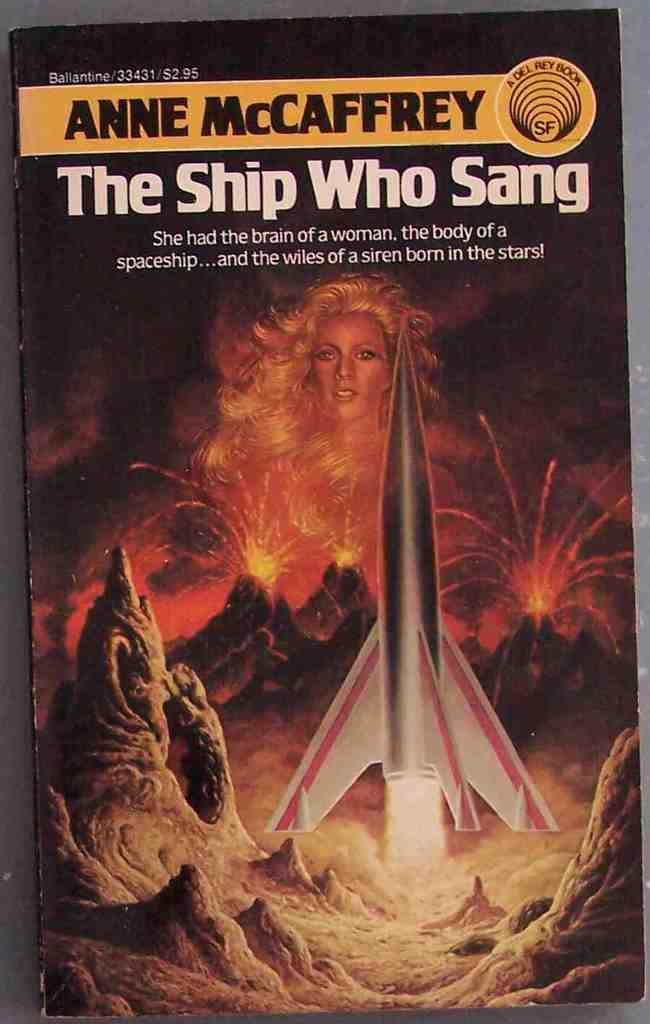Provide a one-sentence caption for the provided image. A woman is seen in a picture behind a rocket ship and volcanoes on a book called "The Ship Who Sang". 